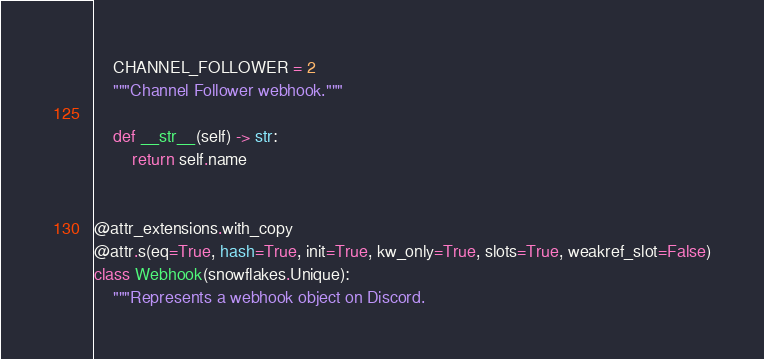<code> <loc_0><loc_0><loc_500><loc_500><_Python_>
    CHANNEL_FOLLOWER = 2
    """Channel Follower webhook."""

    def __str__(self) -> str:
        return self.name


@attr_extensions.with_copy
@attr.s(eq=True, hash=True, init=True, kw_only=True, slots=True, weakref_slot=False)
class Webhook(snowflakes.Unique):
    """Represents a webhook object on Discord.
</code> 